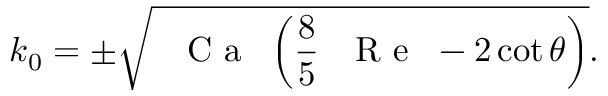Convert formula to latex. <formula><loc_0><loc_0><loc_500><loc_500>k _ { 0 } = \pm \sqrt { { C a } \left ( \frac { 8 } { 5 } { R e } - 2 \cot \theta \right ) } .</formula> 